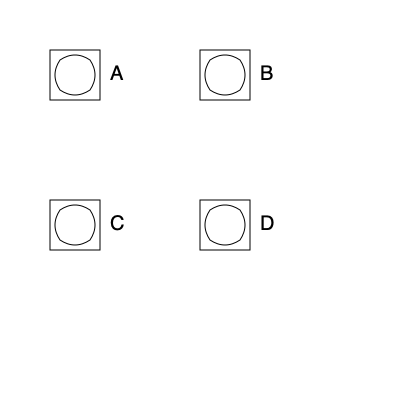Which rotation of the ancient Phoenician letter 'ayin' (ع) is correctly oriented according to its standard use in early Semitic scripts? To determine the correct orientation of the Phoenician letter 'ayin', we need to follow these steps:

1. Recognize the symbol: The symbol shown is a representation of the Phoenician letter 'ayin', which later evolved into the Arabic letter 'ain' (ع).

2. Understand the historical context: The Phoenician alphabet is read from right to left, which influences the orientation of its letters.

3. Analyze the symbol's features:
   a. The 'ayin' typically has a circular or oval shape.
   b. It often has an opening or gap on one side.

4. Compare with standard orientation:
   a. In early Semitic scripts, the 'ayin' is usually oriented with the opening facing right or slightly upward-right.
   b. This orientation facilitates the right-to-left writing direction.

5. Examine the given options:
   A: Opening faces left and slightly downward
   B: Opening faces right and slightly upward (correct orientation)
   C: Opening faces left and slightly upward
   D: Opening faces right and slightly downward

6. Conclude: Option B shows the correct orientation, with the opening facing right and slightly upward, matching the standard use in early Semitic scripts.
Answer: B 